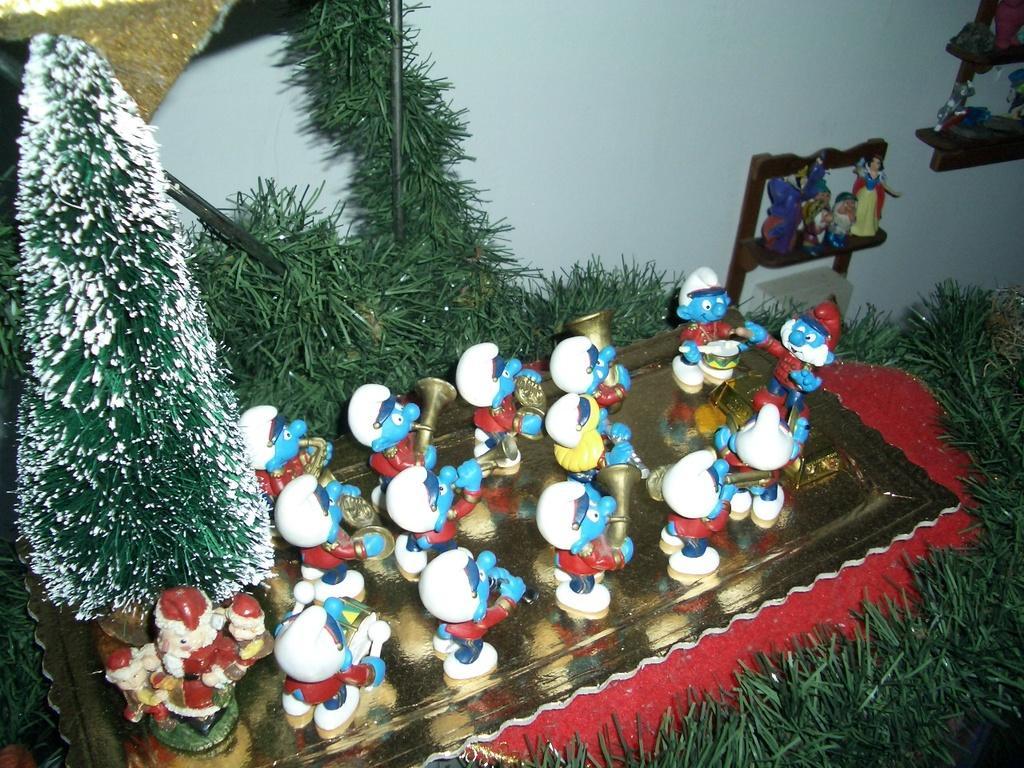How would you summarize this image in a sentence or two? In this picture we can see grass, toys on a platform, trees and in the background we can see wall. 